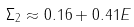<formula> <loc_0><loc_0><loc_500><loc_500>\Sigma _ { 2 } \approx 0 . 1 6 + 0 . 4 1 E</formula> 